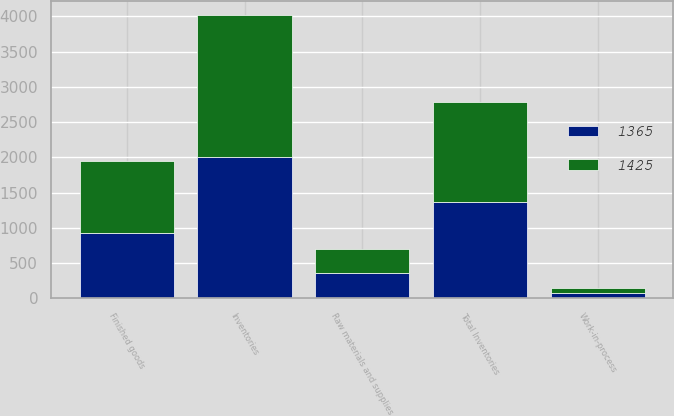<chart> <loc_0><loc_0><loc_500><loc_500><stacked_bar_chart><ecel><fcel>Inventories<fcel>Raw materials and supplies<fcel>Work-in-process<fcel>Finished goods<fcel>Total Inventories<nl><fcel>1425<fcel>2013<fcel>340<fcel>60<fcel>1025<fcel>1425<nl><fcel>1365<fcel>2012<fcel>362<fcel>81<fcel>922<fcel>1365<nl></chart> 